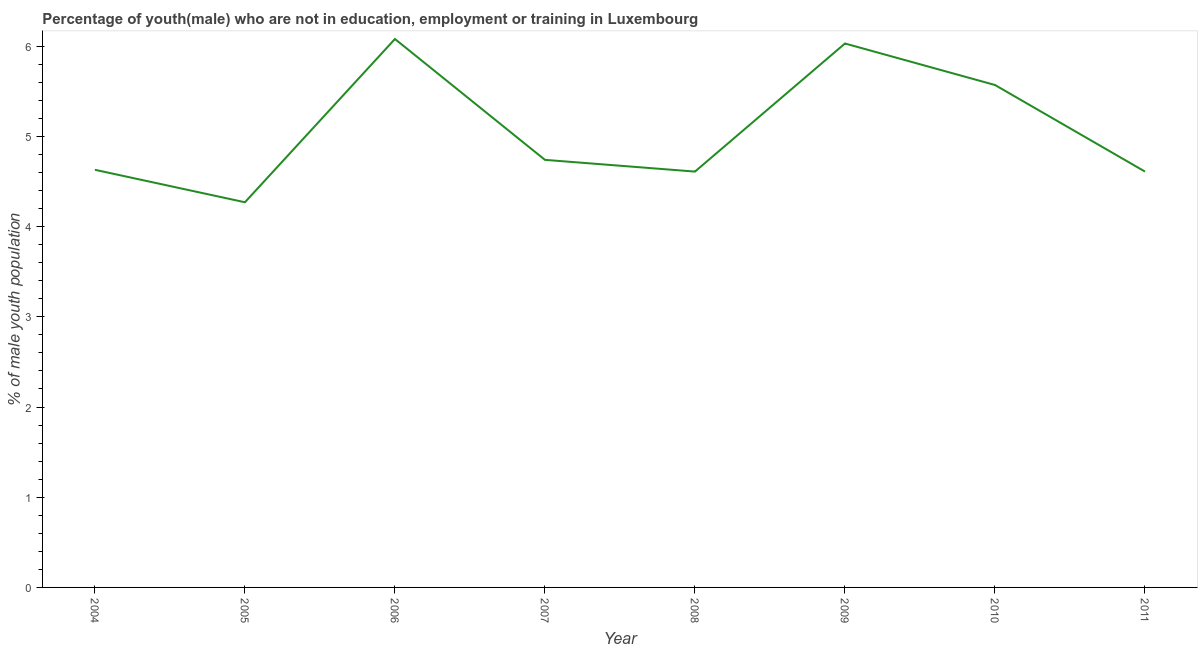What is the unemployed male youth population in 2010?
Make the answer very short. 5.57. Across all years, what is the maximum unemployed male youth population?
Your answer should be very brief. 6.08. Across all years, what is the minimum unemployed male youth population?
Give a very brief answer. 4.27. What is the sum of the unemployed male youth population?
Ensure brevity in your answer.  40.54. What is the difference between the unemployed male youth population in 2004 and 2006?
Your response must be concise. -1.45. What is the average unemployed male youth population per year?
Your response must be concise. 5.07. What is the median unemployed male youth population?
Your response must be concise. 4.68. What is the ratio of the unemployed male youth population in 2005 to that in 2007?
Your answer should be very brief. 0.9. What is the difference between the highest and the second highest unemployed male youth population?
Make the answer very short. 0.05. Is the sum of the unemployed male youth population in 2004 and 2006 greater than the maximum unemployed male youth population across all years?
Ensure brevity in your answer.  Yes. What is the difference between the highest and the lowest unemployed male youth population?
Your response must be concise. 1.81. How many lines are there?
Your response must be concise. 1. How many years are there in the graph?
Offer a terse response. 8. Are the values on the major ticks of Y-axis written in scientific E-notation?
Provide a succinct answer. No. Does the graph contain any zero values?
Ensure brevity in your answer.  No. What is the title of the graph?
Provide a succinct answer. Percentage of youth(male) who are not in education, employment or training in Luxembourg. What is the label or title of the Y-axis?
Provide a succinct answer. % of male youth population. What is the % of male youth population of 2004?
Your response must be concise. 4.63. What is the % of male youth population of 2005?
Your response must be concise. 4.27. What is the % of male youth population of 2006?
Your response must be concise. 6.08. What is the % of male youth population in 2007?
Provide a short and direct response. 4.74. What is the % of male youth population in 2008?
Ensure brevity in your answer.  4.61. What is the % of male youth population of 2009?
Offer a very short reply. 6.03. What is the % of male youth population of 2010?
Provide a succinct answer. 5.57. What is the % of male youth population in 2011?
Provide a succinct answer. 4.61. What is the difference between the % of male youth population in 2004 and 2005?
Offer a terse response. 0.36. What is the difference between the % of male youth population in 2004 and 2006?
Provide a succinct answer. -1.45. What is the difference between the % of male youth population in 2004 and 2007?
Keep it short and to the point. -0.11. What is the difference between the % of male youth population in 2004 and 2008?
Your response must be concise. 0.02. What is the difference between the % of male youth population in 2004 and 2010?
Your answer should be very brief. -0.94. What is the difference between the % of male youth population in 2005 and 2006?
Offer a very short reply. -1.81. What is the difference between the % of male youth population in 2005 and 2007?
Offer a very short reply. -0.47. What is the difference between the % of male youth population in 2005 and 2008?
Offer a very short reply. -0.34. What is the difference between the % of male youth population in 2005 and 2009?
Your answer should be compact. -1.76. What is the difference between the % of male youth population in 2005 and 2010?
Provide a succinct answer. -1.3. What is the difference between the % of male youth population in 2005 and 2011?
Your answer should be compact. -0.34. What is the difference between the % of male youth population in 2006 and 2007?
Offer a very short reply. 1.34. What is the difference between the % of male youth population in 2006 and 2008?
Your answer should be very brief. 1.47. What is the difference between the % of male youth population in 2006 and 2009?
Your answer should be compact. 0.05. What is the difference between the % of male youth population in 2006 and 2010?
Your answer should be compact. 0.51. What is the difference between the % of male youth population in 2006 and 2011?
Your response must be concise. 1.47. What is the difference between the % of male youth population in 2007 and 2008?
Offer a very short reply. 0.13. What is the difference between the % of male youth population in 2007 and 2009?
Your response must be concise. -1.29. What is the difference between the % of male youth population in 2007 and 2010?
Provide a succinct answer. -0.83. What is the difference between the % of male youth population in 2007 and 2011?
Make the answer very short. 0.13. What is the difference between the % of male youth population in 2008 and 2009?
Ensure brevity in your answer.  -1.42. What is the difference between the % of male youth population in 2008 and 2010?
Make the answer very short. -0.96. What is the difference between the % of male youth population in 2008 and 2011?
Your answer should be very brief. 0. What is the difference between the % of male youth population in 2009 and 2010?
Provide a short and direct response. 0.46. What is the difference between the % of male youth population in 2009 and 2011?
Your answer should be very brief. 1.42. What is the difference between the % of male youth population in 2010 and 2011?
Give a very brief answer. 0.96. What is the ratio of the % of male youth population in 2004 to that in 2005?
Offer a terse response. 1.08. What is the ratio of the % of male youth population in 2004 to that in 2006?
Your answer should be compact. 0.76. What is the ratio of the % of male youth population in 2004 to that in 2008?
Your response must be concise. 1. What is the ratio of the % of male youth population in 2004 to that in 2009?
Make the answer very short. 0.77. What is the ratio of the % of male youth population in 2004 to that in 2010?
Make the answer very short. 0.83. What is the ratio of the % of male youth population in 2005 to that in 2006?
Your answer should be very brief. 0.7. What is the ratio of the % of male youth population in 2005 to that in 2007?
Provide a short and direct response. 0.9. What is the ratio of the % of male youth population in 2005 to that in 2008?
Offer a terse response. 0.93. What is the ratio of the % of male youth population in 2005 to that in 2009?
Offer a terse response. 0.71. What is the ratio of the % of male youth population in 2005 to that in 2010?
Make the answer very short. 0.77. What is the ratio of the % of male youth population in 2005 to that in 2011?
Keep it short and to the point. 0.93. What is the ratio of the % of male youth population in 2006 to that in 2007?
Offer a terse response. 1.28. What is the ratio of the % of male youth population in 2006 to that in 2008?
Offer a very short reply. 1.32. What is the ratio of the % of male youth population in 2006 to that in 2010?
Give a very brief answer. 1.09. What is the ratio of the % of male youth population in 2006 to that in 2011?
Provide a succinct answer. 1.32. What is the ratio of the % of male youth population in 2007 to that in 2008?
Your response must be concise. 1.03. What is the ratio of the % of male youth population in 2007 to that in 2009?
Offer a very short reply. 0.79. What is the ratio of the % of male youth population in 2007 to that in 2010?
Your answer should be compact. 0.85. What is the ratio of the % of male youth population in 2007 to that in 2011?
Make the answer very short. 1.03. What is the ratio of the % of male youth population in 2008 to that in 2009?
Provide a succinct answer. 0.77. What is the ratio of the % of male youth population in 2008 to that in 2010?
Your answer should be compact. 0.83. What is the ratio of the % of male youth population in 2008 to that in 2011?
Make the answer very short. 1. What is the ratio of the % of male youth population in 2009 to that in 2010?
Provide a short and direct response. 1.08. What is the ratio of the % of male youth population in 2009 to that in 2011?
Your answer should be very brief. 1.31. What is the ratio of the % of male youth population in 2010 to that in 2011?
Your answer should be very brief. 1.21. 